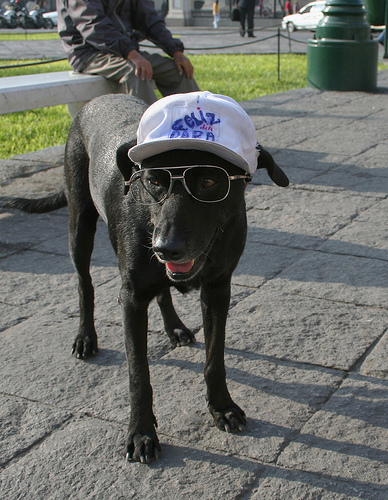Are there any other distinguishing features about the dog we can see in the image? Aside from its stylish accessories, the dog appears to be a mature, black-furred canine with attentive eyes and a healthy coat. It displays a friendly demeanor with its tongue out, which often indicates a relaxed and happy state. 